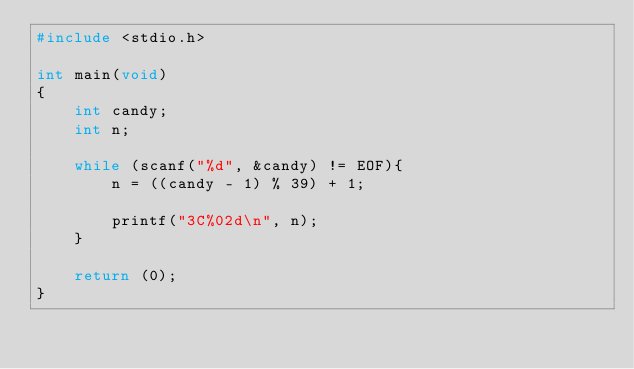<code> <loc_0><loc_0><loc_500><loc_500><_C_>#include <stdio.h>

int main(void)
{
	int candy;
	int n;

	while (scanf("%d", &candy) != EOF){
		n = ((candy - 1) % 39) + 1;
	
		printf("3C%02d\n", n);
	}
	
	return (0);
}</code> 